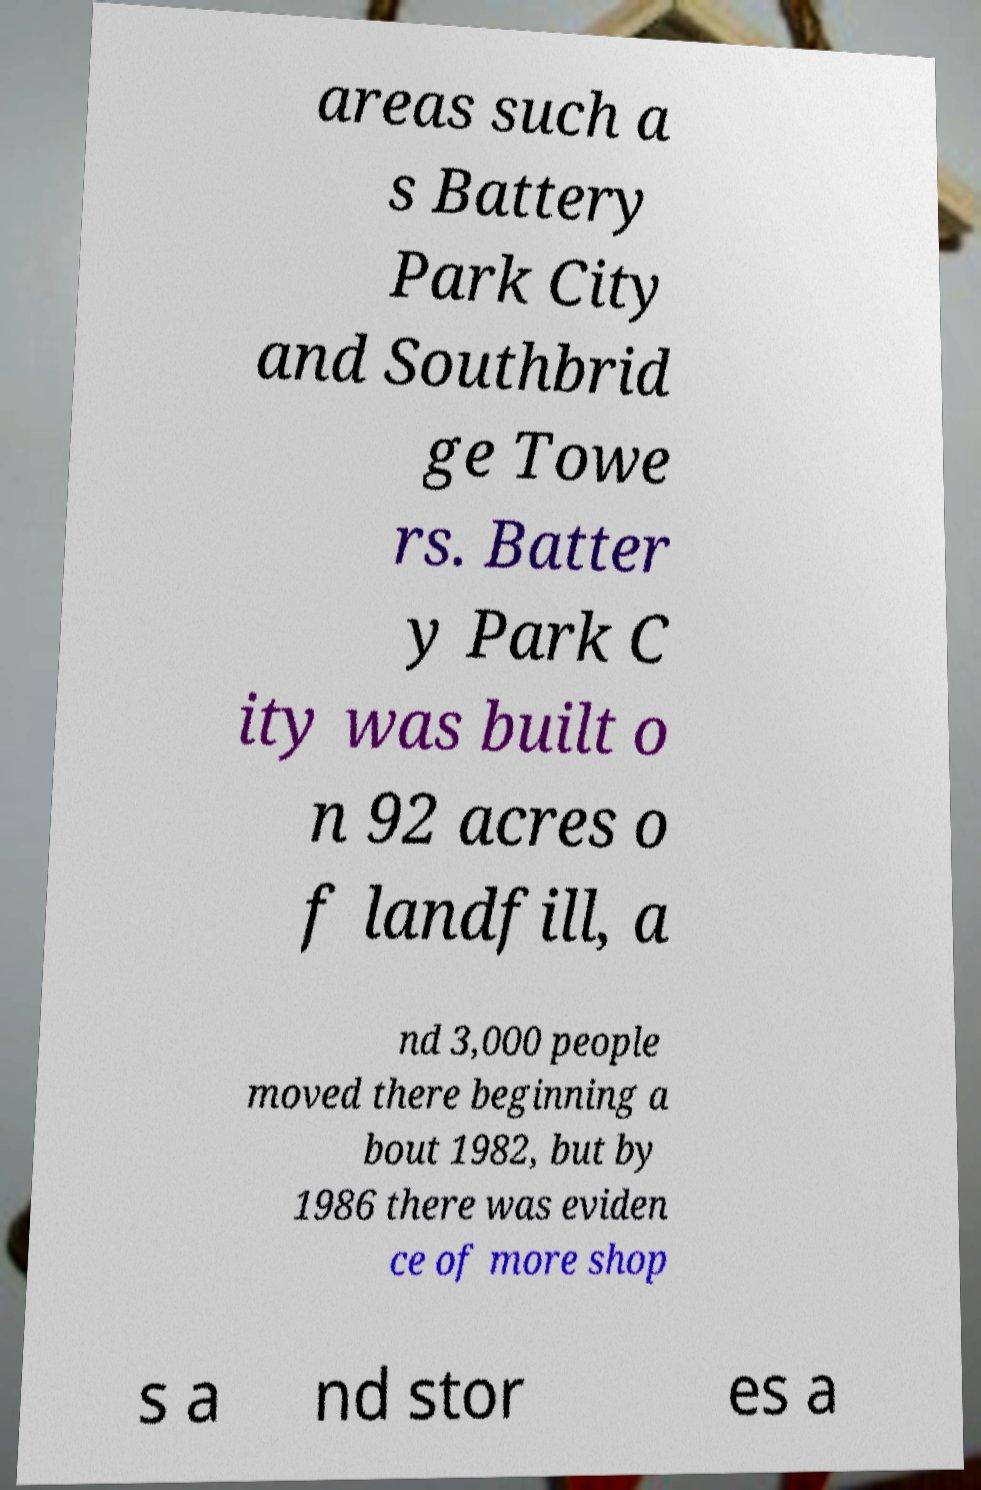Please read and relay the text visible in this image. What does it say? areas such a s Battery Park City and Southbrid ge Towe rs. Batter y Park C ity was built o n 92 acres o f landfill, a nd 3,000 people moved there beginning a bout 1982, but by 1986 there was eviden ce of more shop s a nd stor es a 